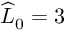<formula> <loc_0><loc_0><loc_500><loc_500>\widehat { L } _ { 0 } = 3</formula> 